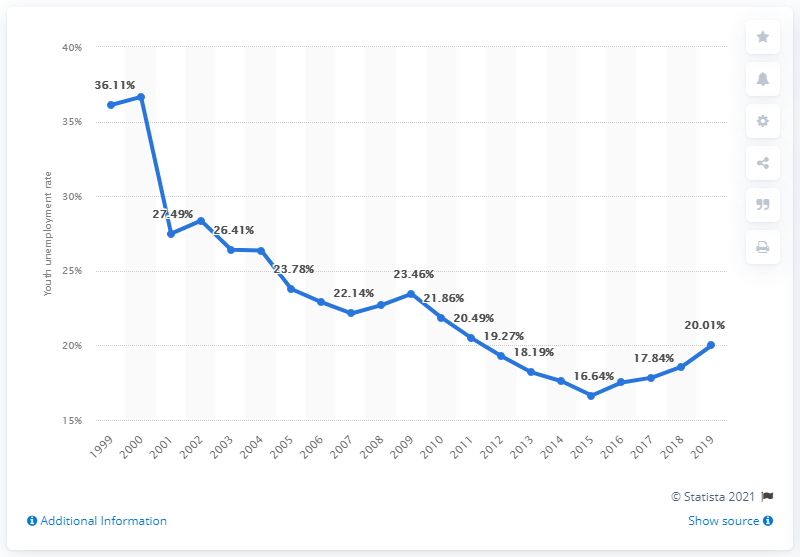Specify some key components in this picture. In 2019, the youth unemployment rate in Colombia was 20.01%. 